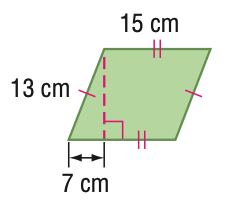Answer the mathemtical geometry problem and directly provide the correct option letter.
Question: Find the perimeter of the figure. Round to the nearest tenth if necessary.
Choices: A: 28 B: 56 C: 112 D: 164 B 